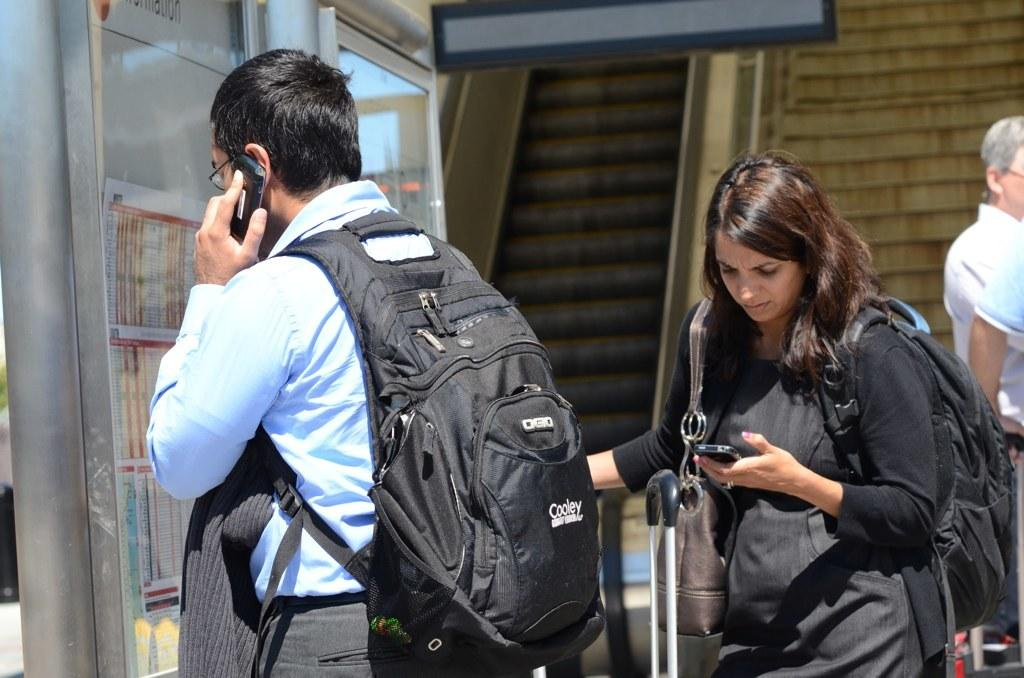Provide a one-sentence caption for the provided image. Man and Woman using their smartphones, The man has a Cooley backpack. 